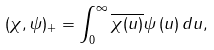Convert formula to latex. <formula><loc_0><loc_0><loc_500><loc_500>( \chi , \psi ) _ { + } = \int _ { 0 } ^ { \infty } \overline { \chi ( u ) } \psi \left ( u \right ) d u ,</formula> 